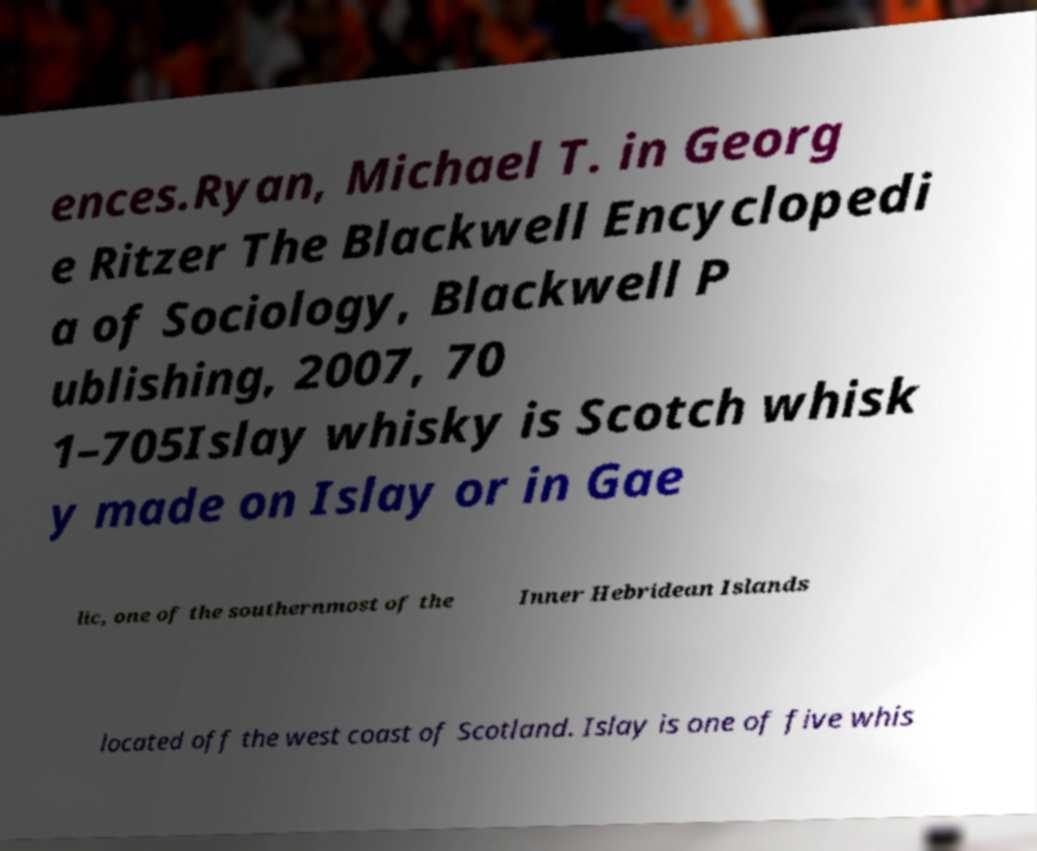Can you accurately transcribe the text from the provided image for me? ences.Ryan, Michael T. in Georg e Ritzer The Blackwell Encyclopedi a of Sociology, Blackwell P ublishing, 2007, 70 1–705Islay whisky is Scotch whisk y made on Islay or in Gae lic, one of the southernmost of the Inner Hebridean Islands located off the west coast of Scotland. Islay is one of five whis 